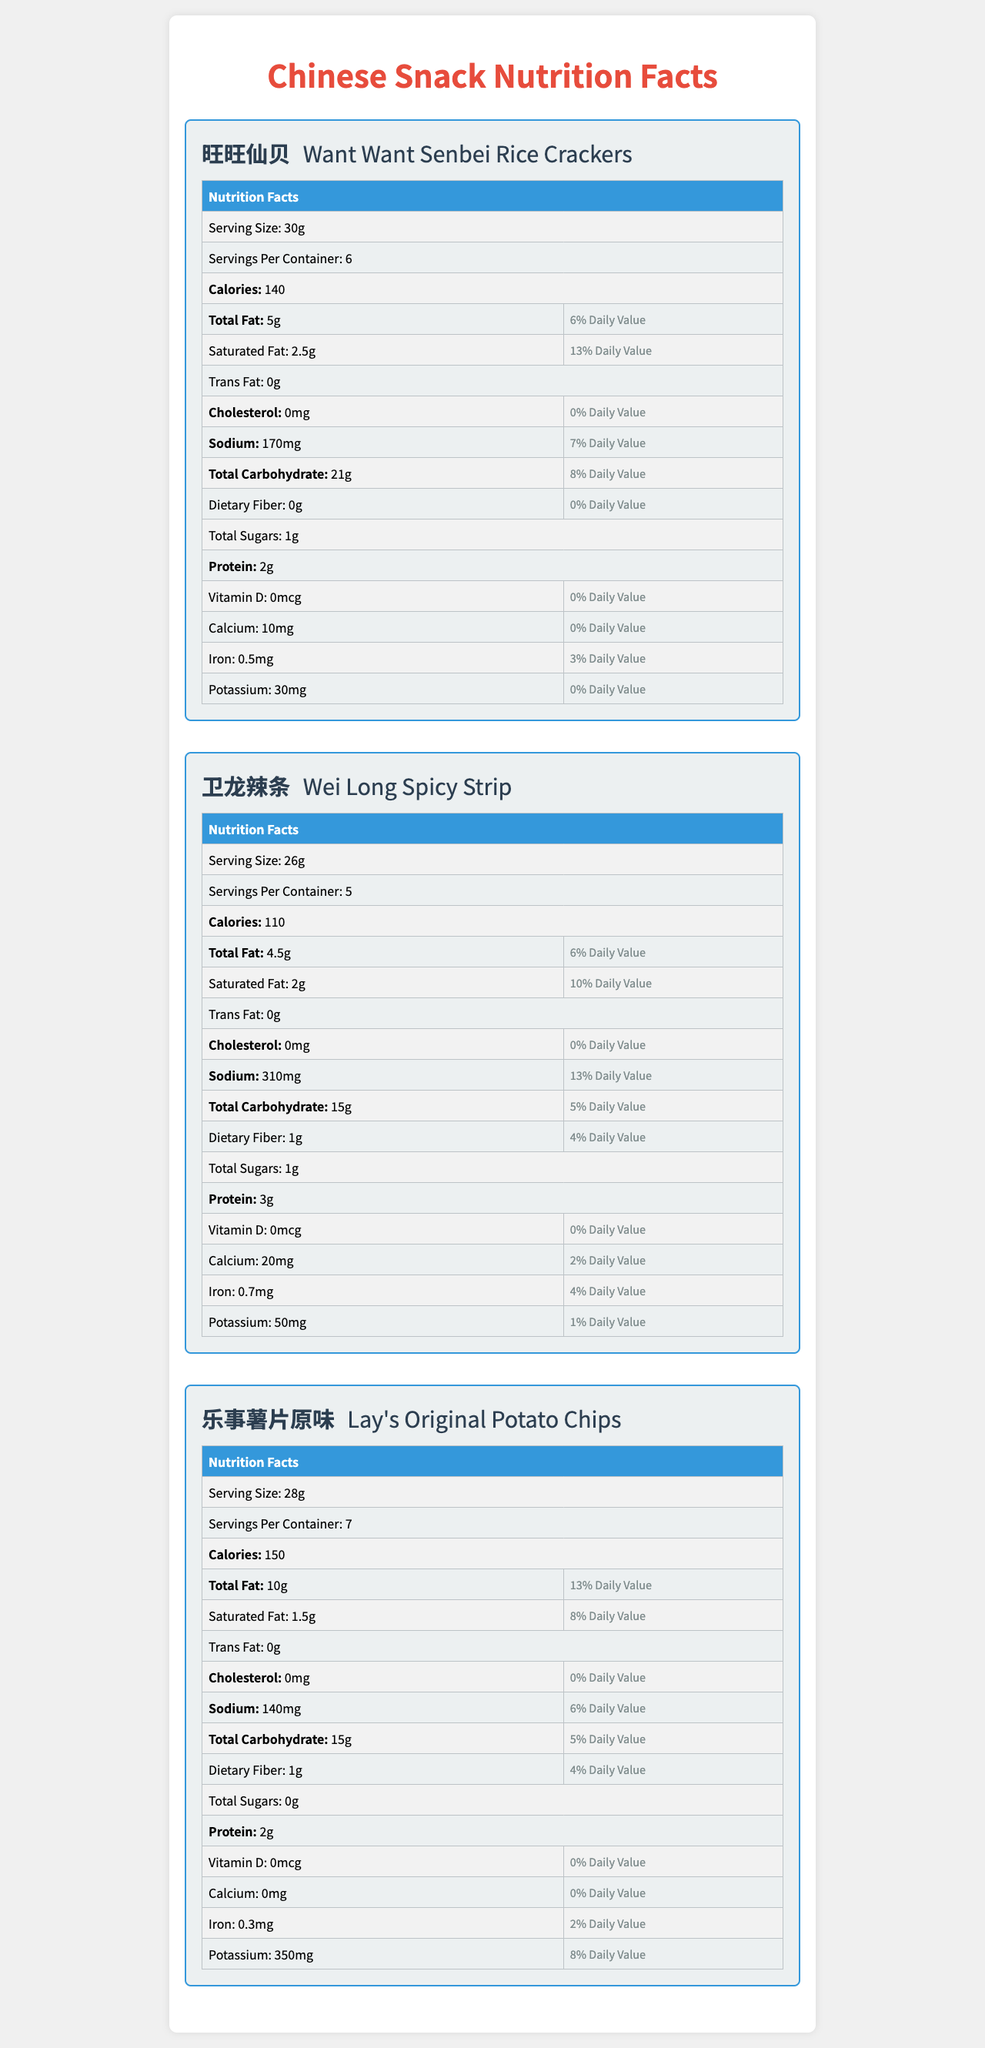what is the serving size of Want Want Senbei Rice Crackers? The serving size information is provided directly in the Nutrition Facts section under Want Want Senbei Rice Crackers.
Answer: 30g how many servings are there per container of Wei Long Spicy Strip? The document states that there are 5 servings per container for Wei Long Spicy Strip.
Answer: 5 what is the total fat content per serving for Lay's Original Potato Chips? Total fat content is listed as 10g in the Nutrition Facts section for Lay's Original Potato Chips.
Answer: 10g how much protein does Want Want Senbei Rice Crackers contain per serving? According to the Nutrition Facts, Want Want Senbei Rice Crackers contain 2g of protein per serving.
Answer: 2g how much sodium is in a serving of Wei Long Spicy Strip? The amount of sodium per serving for Wei Long Spicy Strip is 310mg as per the Nutrition Facts.
Answer: 310mg which snack has the highest calorie count per serving? A. Want Want Senbei Rice Crackers B. Wei Long Spicy Strip C. Lay's Original Potato Chips Lay's Original Potato Chips have 150 calories per serving, which is higher than Want Want Senbei Rice Crackers (140 calories) and Wei Long Spicy Strip (110 calories).
Answer: C which snack has the highest serving size? A. Want Want Senbei Rice Crackers B. Wei Long Spicy Strip C. Lay's Original Potato Chips Want Want Senbei Rice Crackers have the highest serving size (30g), whereas Wei Long Spicy Strip has 26g and Lay's Original Potato Chips has 28g.
Answer: A is there any trans fat in Lay's Original Potato Chips? The Nutrition Facts label for Lay's Original Potato Chips shows 0g trans fat.
Answer: No are there any vitamins in Wei Long Spicy Strip? The Nutrition Facts label specifically mentions 0mcg of Vitamin D for Wei Long Spicy Strip, and it does not list any other vitamins.
Answer: No summarize the main idea of the document. The main focus of the document is to give a comprehensive look at the nutritional information for these three snacks to help consumers make informed decisions about their dietary intake.
Answer: The document provides detailed Nutrition Facts for three popular Chinese snacks: Want Want Senbei Rice Crackers, Wei Long Spicy Strip, and Lay's Original Potato Chips, including information on serving size, servings per container, calories, fat, cholesterol, sodium, carbohydrates, fiber, sugars, protein, and various vitamins and minerals. how many calories are there in the entire container of Want Want Senbei Rice Crackers? To find the total calories in the entire container, we need to multiply the calories per serving by the number of servings per container. The Nutrition Facts only provide per serving information, and the total calculation is not specifically mentioned.
Answer: Not enough information 